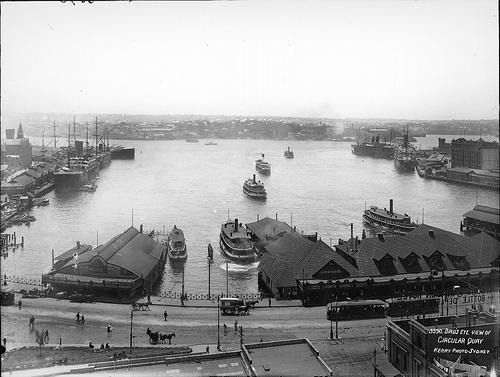Is this picture in present time?
Keep it brief. No. What is in the water?
Be succinct. Boats. What is stretched across the water in the background?
Concise answer only. Land. Is the water choppy?
Concise answer only. No. 